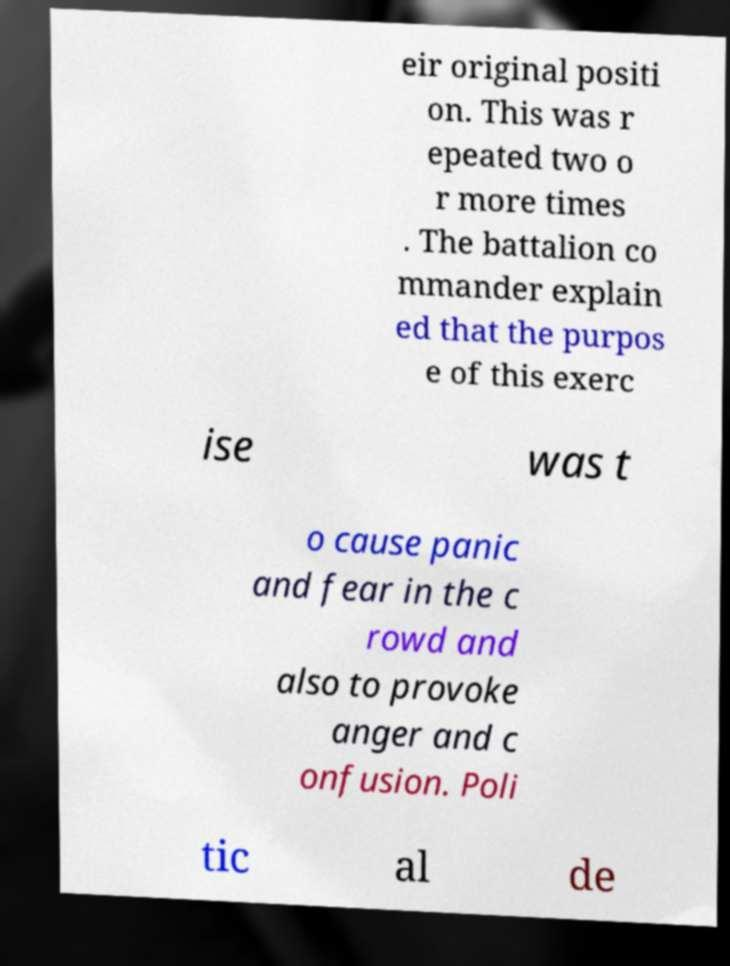Please identify and transcribe the text found in this image. eir original positi on. This was r epeated two o r more times . The battalion co mmander explain ed that the purpos e of this exerc ise was t o cause panic and fear in the c rowd and also to provoke anger and c onfusion. Poli tic al de 